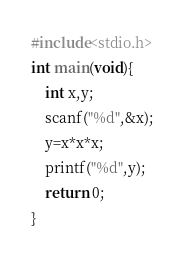<code> <loc_0><loc_0><loc_500><loc_500><_C_>#include<stdio.h>
int main(void){
	int x,y;
	scanf("%d",&x);
	y=x*x*x;
	printf("%d",y);
	return 0;
}</code> 